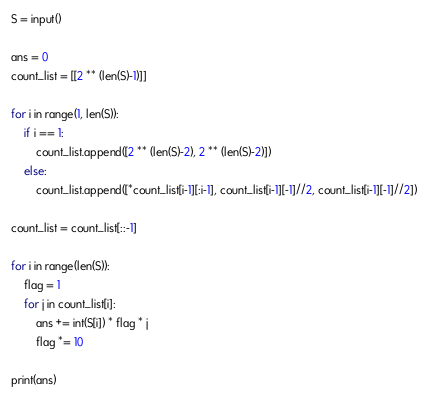<code> <loc_0><loc_0><loc_500><loc_500><_Python_>S = input()

ans = 0
count_list = [[2 ** (len(S)-1)]]

for i in range(1, len(S)):
    if i == 1:
        count_list.append([2 ** (len(S)-2), 2 ** (len(S)-2)])
    else:
        count_list.append([*count_list[i-1][:i-1], count_list[i-1][-1]//2, count_list[i-1][-1]//2])

count_list = count_list[::-1]

for i in range(len(S)):
    flag = 1
    for j in count_list[i]:
        ans += int(S[i]) * flag * j
        flag *= 10

print(ans)</code> 